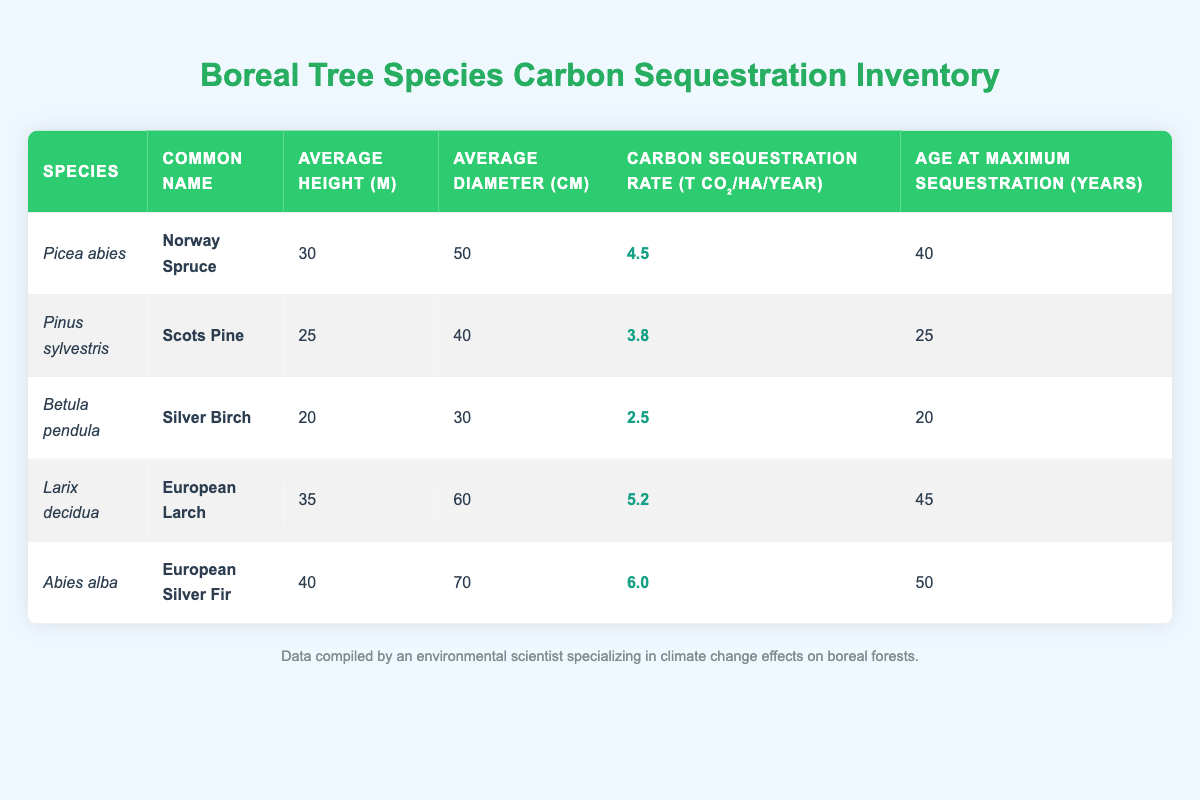What is the carbon sequestration rate of the Norway Spruce? The carbon sequestration rate for Norway Spruce (Picea abies) is listed in the table as 4.5 t CO₂/ha/year.
Answer: 4.5 t CO₂/ha/year Which tree species has the highest average diameter? The average diameters for the species listed are: Norway Spruce (50 cm), Scots Pine (40 cm), Silver Birch (30 cm), European Larch (60 cm), and European Silver Fir (70 cm). The European Silver Fir has the highest average diameter at 70 cm.
Answer: European Silver Fir (70 cm) What is the average maximum age for carbon sequestration across the listed species? To find the average maximum age, we add the maximum ages: 40 (Norway Spruce) + 25 (Scots Pine) + 20 (Silver Birch) + 45 (European Larch) + 50 (European Silver Fir) = 180 years. Then, divide by the number of species (5): 180 / 5 = 36 years.
Answer: 36 years Is the carbon sequestration rate of the Silver Birch greater than 3 t CO₂/ha/year? The carbon sequestration rate of Silver Birch (Betula pendula) is 2.5 t CO₂/ha/year, which is less than 3 t CO₂/ha/year. Therefore, the statement is false.
Answer: No Considering the data, which species reaches maximum sequestration rate the earliest? The ages at maximum sequestration for the species are 40 years (Norway Spruce), 25 years (Scots Pine), 20 years (Silver Birch), 45 years (European Larch), and 50 years (European Silver Fir). Silver Birch reaches its maximum sequestration rate at 20 years, which is the earliest among the species listed.
Answer: Silver Birch What is the difference in carbon sequestration rates between European Silver Fir and Scots Pine? The carbon sequestration rates are 6.0 t CO₂/ha/year for European Silver Fir and 3.8 t CO₂/ha/year for Scots Pine. The difference is calculated as 6.0 - 3.8 = 2.2 t CO₂/ha/year.
Answer: 2.2 t CO₂/ha/year Which species has both the tallest average height and the highest carbon sequestration rate? The average heights are 30 m (Norway Spruce), 25 m (Scots Pine), 20 m (Silver Birch), 35 m (European Larch), and 40 m (European Silver Fir). The tallest is the European Silver Fir at 40 m and it also has the highest sequestration rate of 6.0 t CO₂/ha/year.
Answer: European Silver Fir How many species have a carbon sequestration rate greater than 4 t CO₂/ha/year? The rates for each species are: 4.5 (Norway Spruce), 3.8 (Scots Pine), 2.5 (Silver Birch), 5.2 (European Larch), and 6.0 (European Silver Fir). The species with rates above 4 t CO₂/ha/year are Norway Spruce, European Larch, and European Silver Fir, totaling 3 species.
Answer: 3 species 